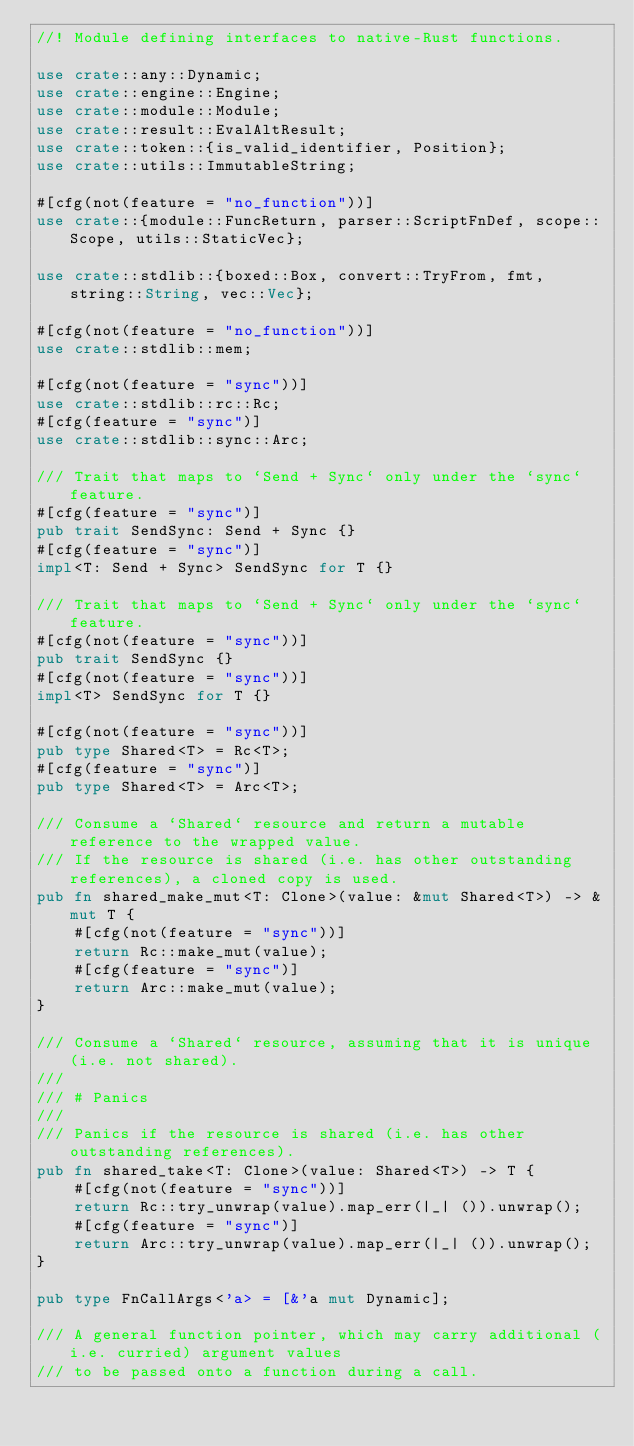<code> <loc_0><loc_0><loc_500><loc_500><_Rust_>//! Module defining interfaces to native-Rust functions.

use crate::any::Dynamic;
use crate::engine::Engine;
use crate::module::Module;
use crate::result::EvalAltResult;
use crate::token::{is_valid_identifier, Position};
use crate::utils::ImmutableString;

#[cfg(not(feature = "no_function"))]
use crate::{module::FuncReturn, parser::ScriptFnDef, scope::Scope, utils::StaticVec};

use crate::stdlib::{boxed::Box, convert::TryFrom, fmt, string::String, vec::Vec};

#[cfg(not(feature = "no_function"))]
use crate::stdlib::mem;

#[cfg(not(feature = "sync"))]
use crate::stdlib::rc::Rc;
#[cfg(feature = "sync")]
use crate::stdlib::sync::Arc;

/// Trait that maps to `Send + Sync` only under the `sync` feature.
#[cfg(feature = "sync")]
pub trait SendSync: Send + Sync {}
#[cfg(feature = "sync")]
impl<T: Send + Sync> SendSync for T {}

/// Trait that maps to `Send + Sync` only under the `sync` feature.
#[cfg(not(feature = "sync"))]
pub trait SendSync {}
#[cfg(not(feature = "sync"))]
impl<T> SendSync for T {}

#[cfg(not(feature = "sync"))]
pub type Shared<T> = Rc<T>;
#[cfg(feature = "sync")]
pub type Shared<T> = Arc<T>;

/// Consume a `Shared` resource and return a mutable reference to the wrapped value.
/// If the resource is shared (i.e. has other outstanding references), a cloned copy is used.
pub fn shared_make_mut<T: Clone>(value: &mut Shared<T>) -> &mut T {
    #[cfg(not(feature = "sync"))]
    return Rc::make_mut(value);
    #[cfg(feature = "sync")]
    return Arc::make_mut(value);
}

/// Consume a `Shared` resource, assuming that it is unique (i.e. not shared).
///
/// # Panics
///
/// Panics if the resource is shared (i.e. has other outstanding references).
pub fn shared_take<T: Clone>(value: Shared<T>) -> T {
    #[cfg(not(feature = "sync"))]
    return Rc::try_unwrap(value).map_err(|_| ()).unwrap();
    #[cfg(feature = "sync")]
    return Arc::try_unwrap(value).map_err(|_| ()).unwrap();
}

pub type FnCallArgs<'a> = [&'a mut Dynamic];

/// A general function pointer, which may carry additional (i.e. curried) argument values
/// to be passed onto a function during a call.</code> 